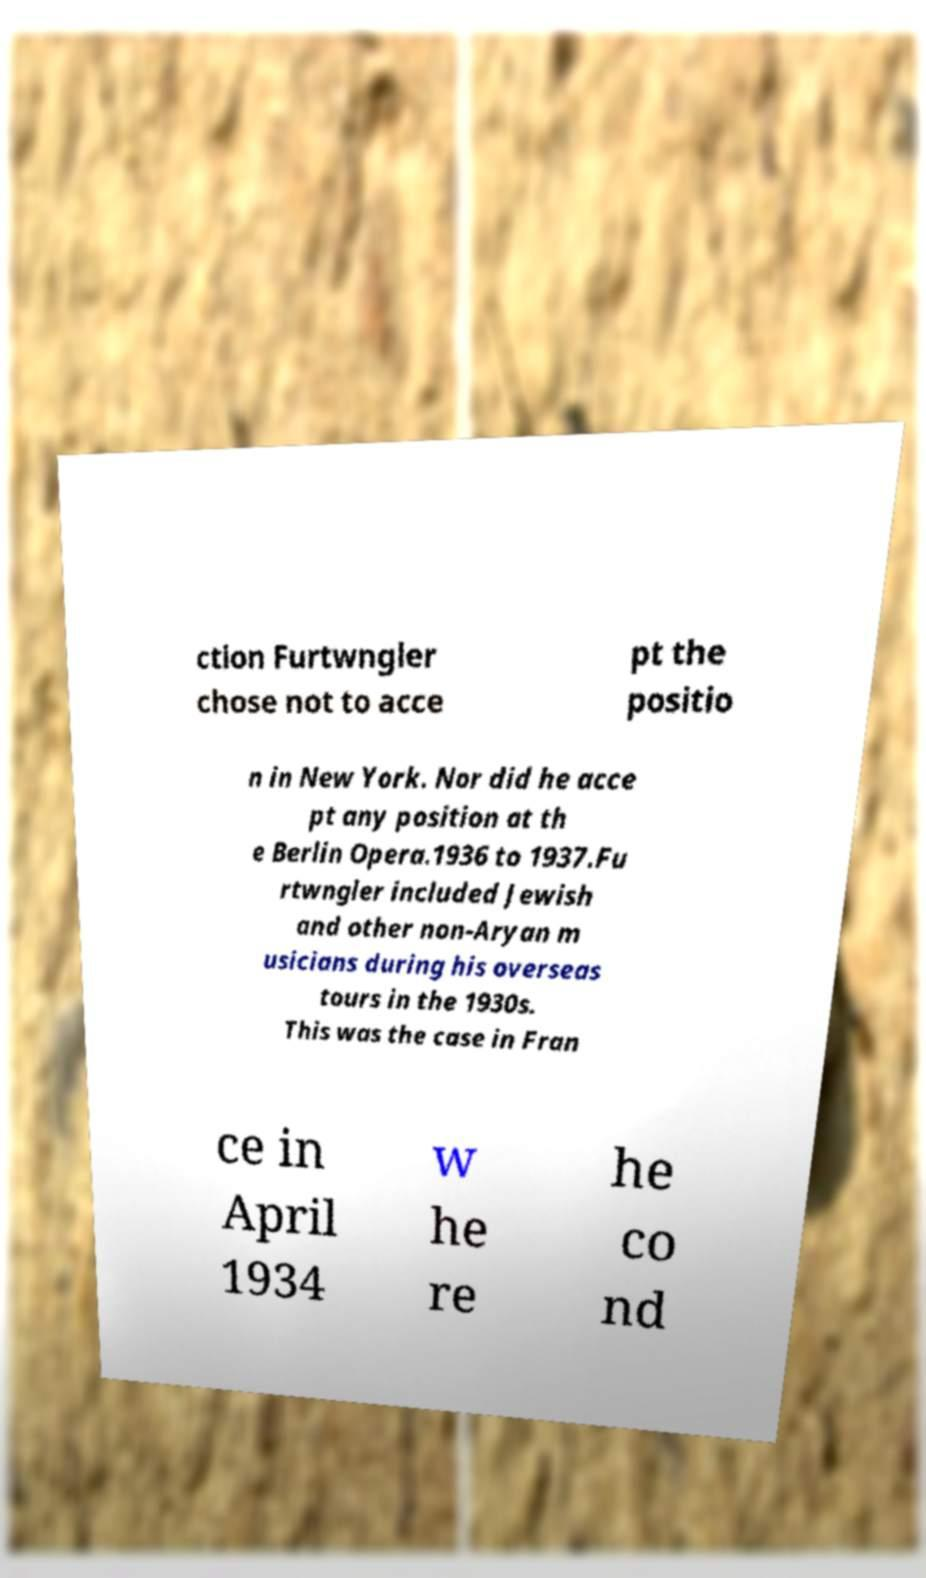Can you read and provide the text displayed in the image?This photo seems to have some interesting text. Can you extract and type it out for me? ction Furtwngler chose not to acce pt the positio n in New York. Nor did he acce pt any position at th e Berlin Opera.1936 to 1937.Fu rtwngler included Jewish and other non-Aryan m usicians during his overseas tours in the 1930s. This was the case in Fran ce in April 1934 w he re he co nd 